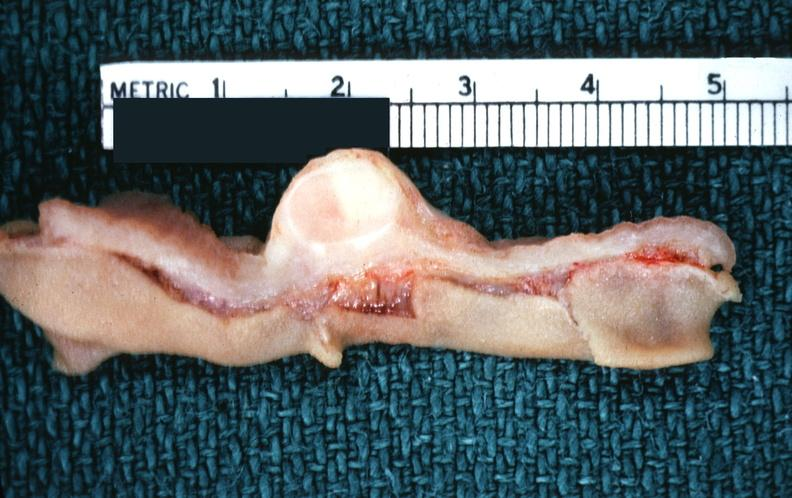what is present?
Answer the question using a single word or phrase. Gastrointestinal 